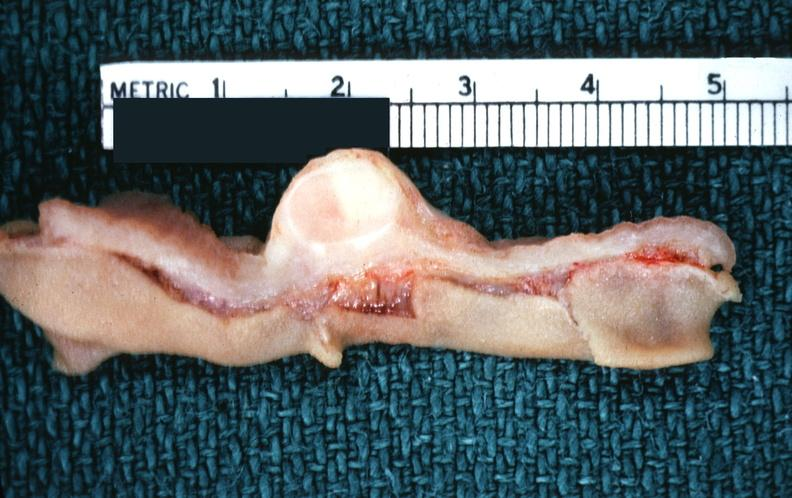what is present?
Answer the question using a single word or phrase. Gastrointestinal 